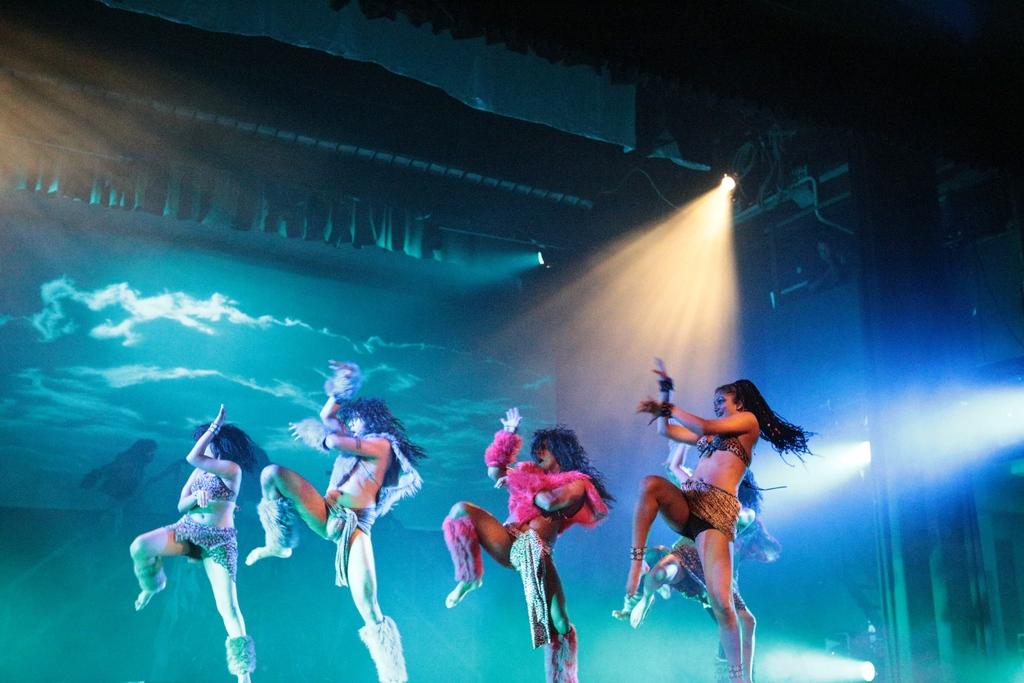What is happening in the image? There are ladies in the image, and they are dancing. Can you describe the light in the image? There is a light visible at the top of the image. What type of box can be seen in the image? There is no box present in the image. How many mice are dancing with the ladies in the image? There are no mice present in the image; only the ladies are dancing. 